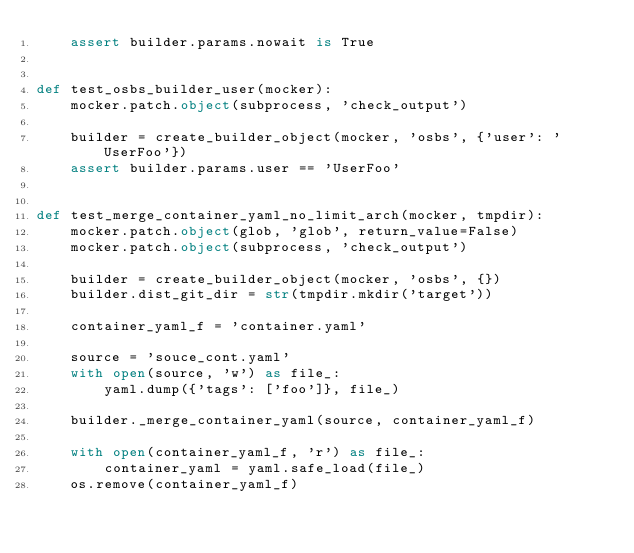Convert code to text. <code><loc_0><loc_0><loc_500><loc_500><_Python_>    assert builder.params.nowait is True


def test_osbs_builder_user(mocker):
    mocker.patch.object(subprocess, 'check_output')

    builder = create_builder_object(mocker, 'osbs', {'user': 'UserFoo'})
    assert builder.params.user == 'UserFoo'


def test_merge_container_yaml_no_limit_arch(mocker, tmpdir):
    mocker.patch.object(glob, 'glob', return_value=False)
    mocker.patch.object(subprocess, 'check_output')

    builder = create_builder_object(mocker, 'osbs', {})
    builder.dist_git_dir = str(tmpdir.mkdir('target'))

    container_yaml_f = 'container.yaml'

    source = 'souce_cont.yaml'
    with open(source, 'w') as file_:
        yaml.dump({'tags': ['foo']}, file_)

    builder._merge_container_yaml(source, container_yaml_f)

    with open(container_yaml_f, 'r') as file_:
        container_yaml = yaml.safe_load(file_)
    os.remove(container_yaml_f)</code> 